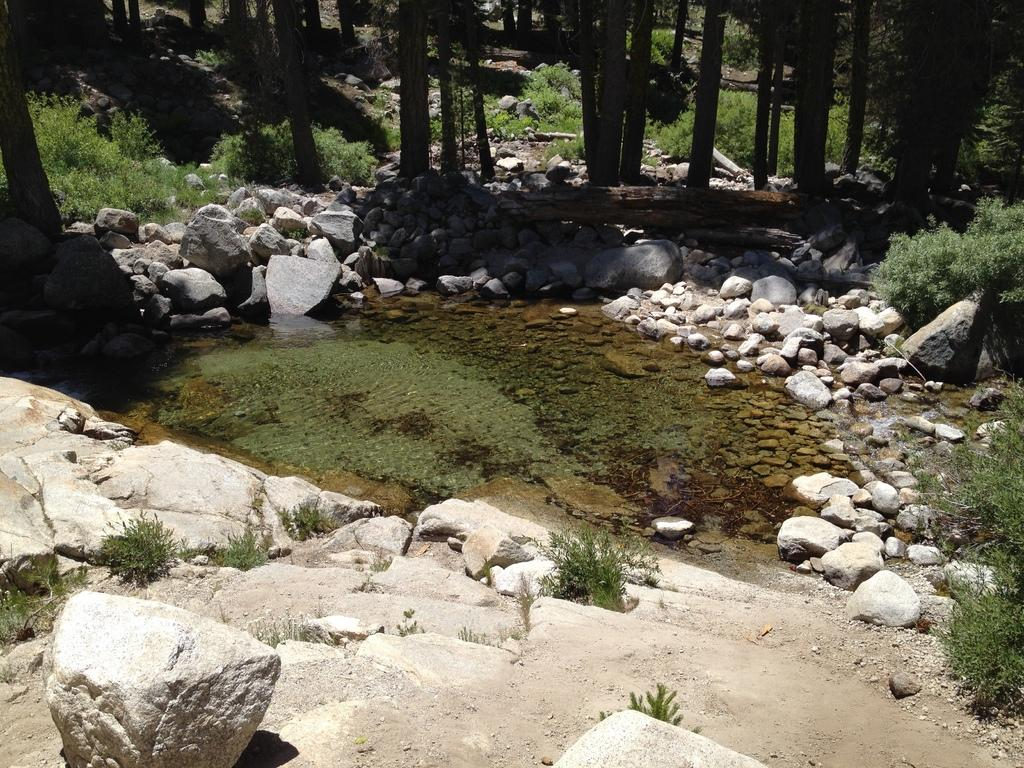What is located in the foreground of the image? There are rocks in the foreground of the image. What is present in the middle of the image? There are rocks and a water body in the middle of the image. What can be seen at the top of the image? There are trees visible at the top of the image. What type of authority figure can be seen in the image? There is no authority figure present in the image. Is there a fireman attending to the water body in the image? There is no fireman present in the image. 